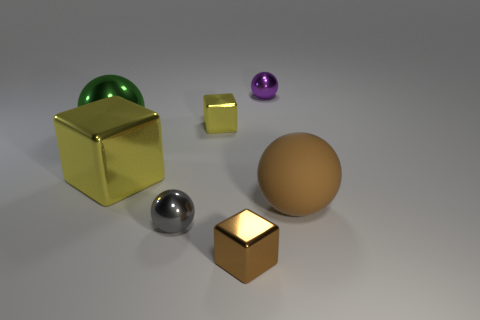Subtract all small blocks. How many blocks are left? 1 Subtract all brown blocks. How many blocks are left? 2 Add 2 big rubber things. How many objects exist? 9 Subtract 3 cubes. How many cubes are left? 0 Subtract all balls. How many objects are left? 3 Subtract all green cylinders. Subtract all tiny gray metal spheres. How many objects are left? 6 Add 7 large yellow things. How many large yellow things are left? 8 Add 6 large yellow metal blocks. How many large yellow metal blocks exist? 7 Subtract 2 yellow blocks. How many objects are left? 5 Subtract all purple spheres. Subtract all brown blocks. How many spheres are left? 3 